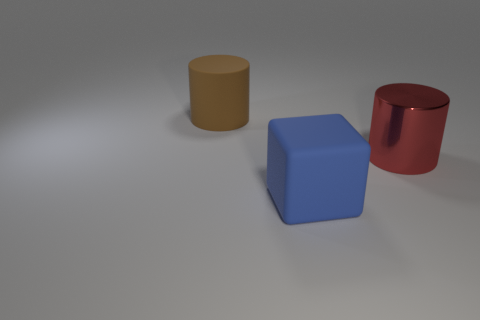There is a large object that is made of the same material as the cube; what is its shape?
Ensure brevity in your answer.  Cylinder. Do the object right of the cube and the rubber object that is in front of the matte cylinder have the same size?
Offer a terse response. Yes. Are there more shiny things on the right side of the blue block than large matte objects on the right side of the red metallic cylinder?
Provide a short and direct response. Yes. There is a large cylinder that is in front of the big brown matte thing; how many things are behind it?
Offer a very short reply. 1. Are there any other things that have the same material as the large red cylinder?
Make the answer very short. No. What material is the big thing that is on the right side of the rubber thing in front of the thing that is left of the blue object made of?
Your answer should be very brief. Metal. What is the big object that is both to the right of the big matte cylinder and to the left of the large red cylinder made of?
Give a very brief answer. Rubber. How many other things have the same shape as the red shiny thing?
Give a very brief answer. 1. There is a thing left of the matte object that is on the right side of the brown rubber thing; what is its size?
Your answer should be compact. Large. How many big matte objects are behind the big cylinder on the right side of the big thing that is behind the big metal thing?
Your answer should be compact. 1. 